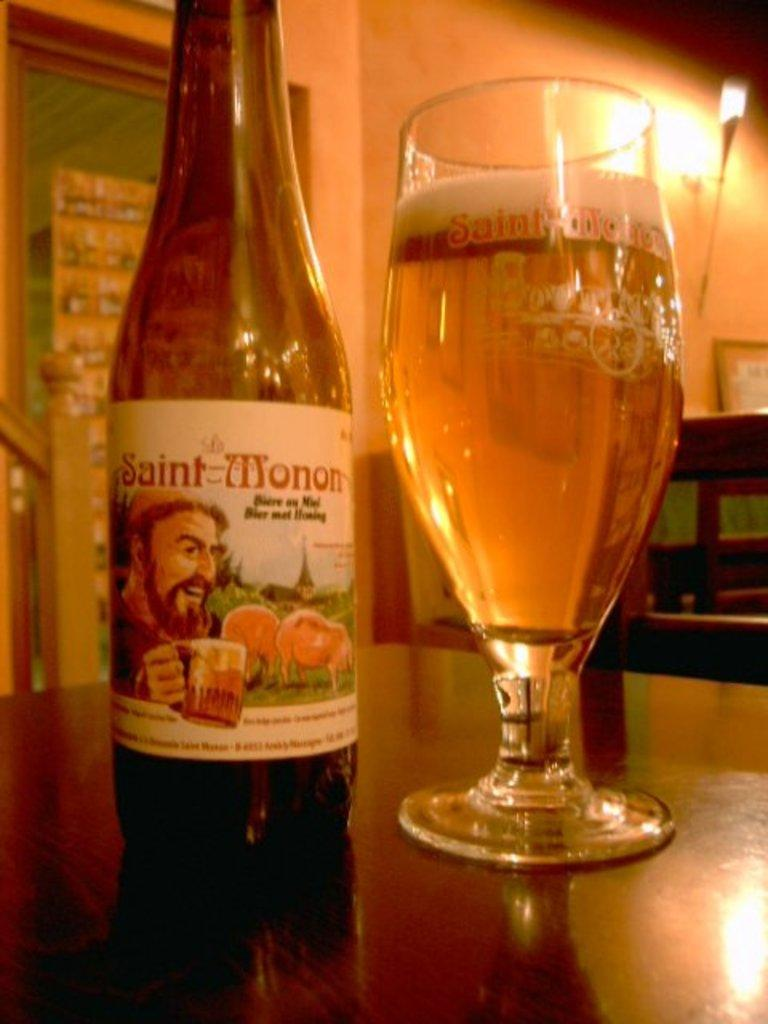What is on the table in the image? There is a bottle with a sticker and a glass with liquid and foam on the table. Can you describe the bottle on the table? The bottle has a sticker on it. What is the purpose of the light on the wall? The light on the wall provides illumination in the image. How many sisters are shown wearing socks in the image? There are no sisters or socks present in the image. 